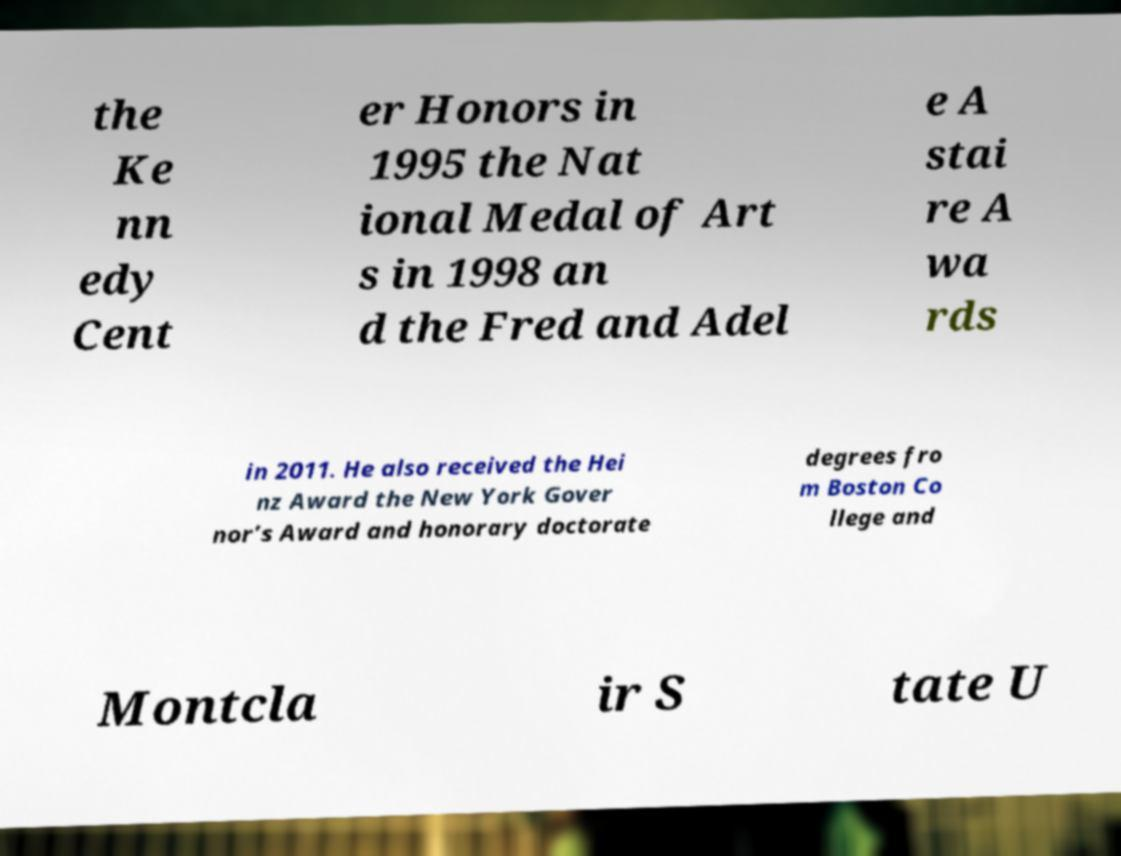There's text embedded in this image that I need extracted. Can you transcribe it verbatim? the Ke nn edy Cent er Honors in 1995 the Nat ional Medal of Art s in 1998 an d the Fred and Adel e A stai re A wa rds in 2011. He also received the Hei nz Award the New York Gover nor’s Award and honorary doctorate degrees fro m Boston Co llege and Montcla ir S tate U 